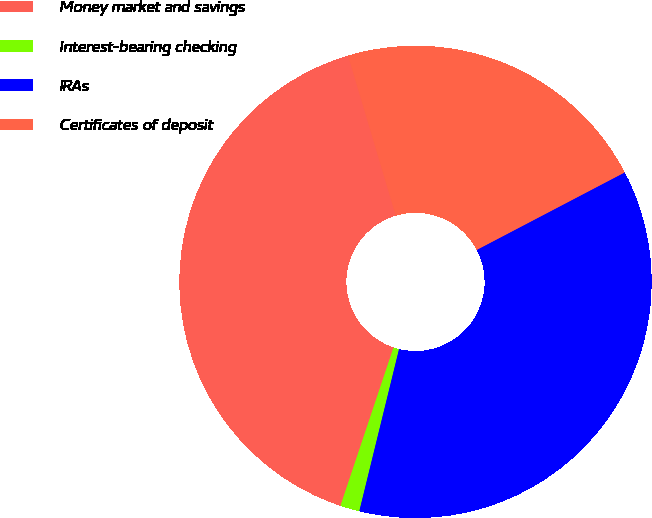Convert chart to OTSL. <chart><loc_0><loc_0><loc_500><loc_500><pie_chart><fcel>Money market and savings<fcel>Interest-bearing checking<fcel>IRAs<fcel>Certificates of deposit<nl><fcel>40.24%<fcel>1.32%<fcel>36.5%<fcel>21.93%<nl></chart> 